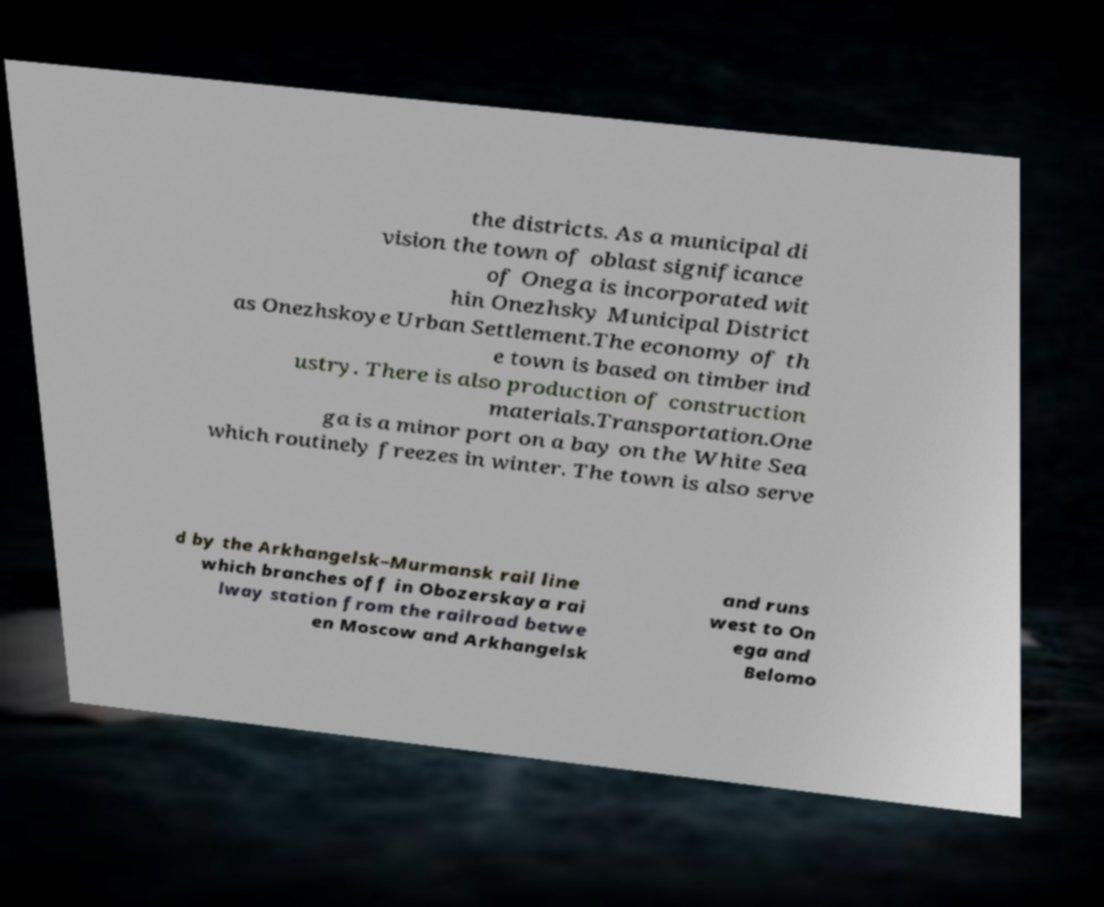Could you extract and type out the text from this image? the districts. As a municipal di vision the town of oblast significance of Onega is incorporated wit hin Onezhsky Municipal District as Onezhskoye Urban Settlement.The economy of th e town is based on timber ind ustry. There is also production of construction materials.Transportation.One ga is a minor port on a bay on the White Sea which routinely freezes in winter. The town is also serve d by the Arkhangelsk–Murmansk rail line which branches off in Obozerskaya rai lway station from the railroad betwe en Moscow and Arkhangelsk and runs west to On ega and Belomo 